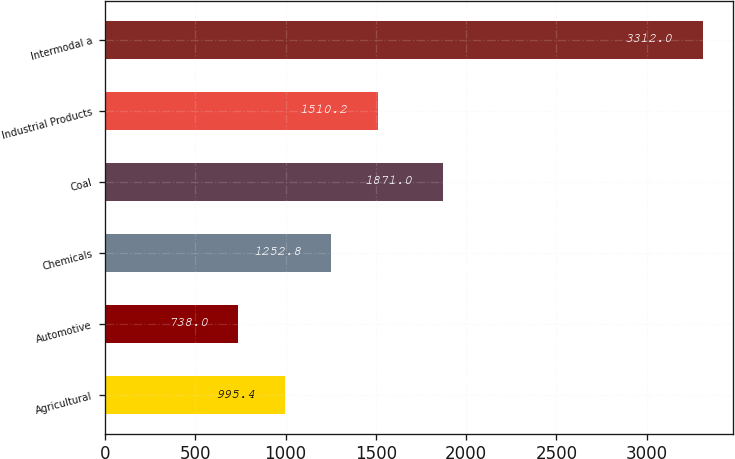Convert chart to OTSL. <chart><loc_0><loc_0><loc_500><loc_500><bar_chart><fcel>Agricultural<fcel>Automotive<fcel>Chemicals<fcel>Coal<fcel>Industrial Products<fcel>Intermodal a<nl><fcel>995.4<fcel>738<fcel>1252.8<fcel>1871<fcel>1510.2<fcel>3312<nl></chart> 